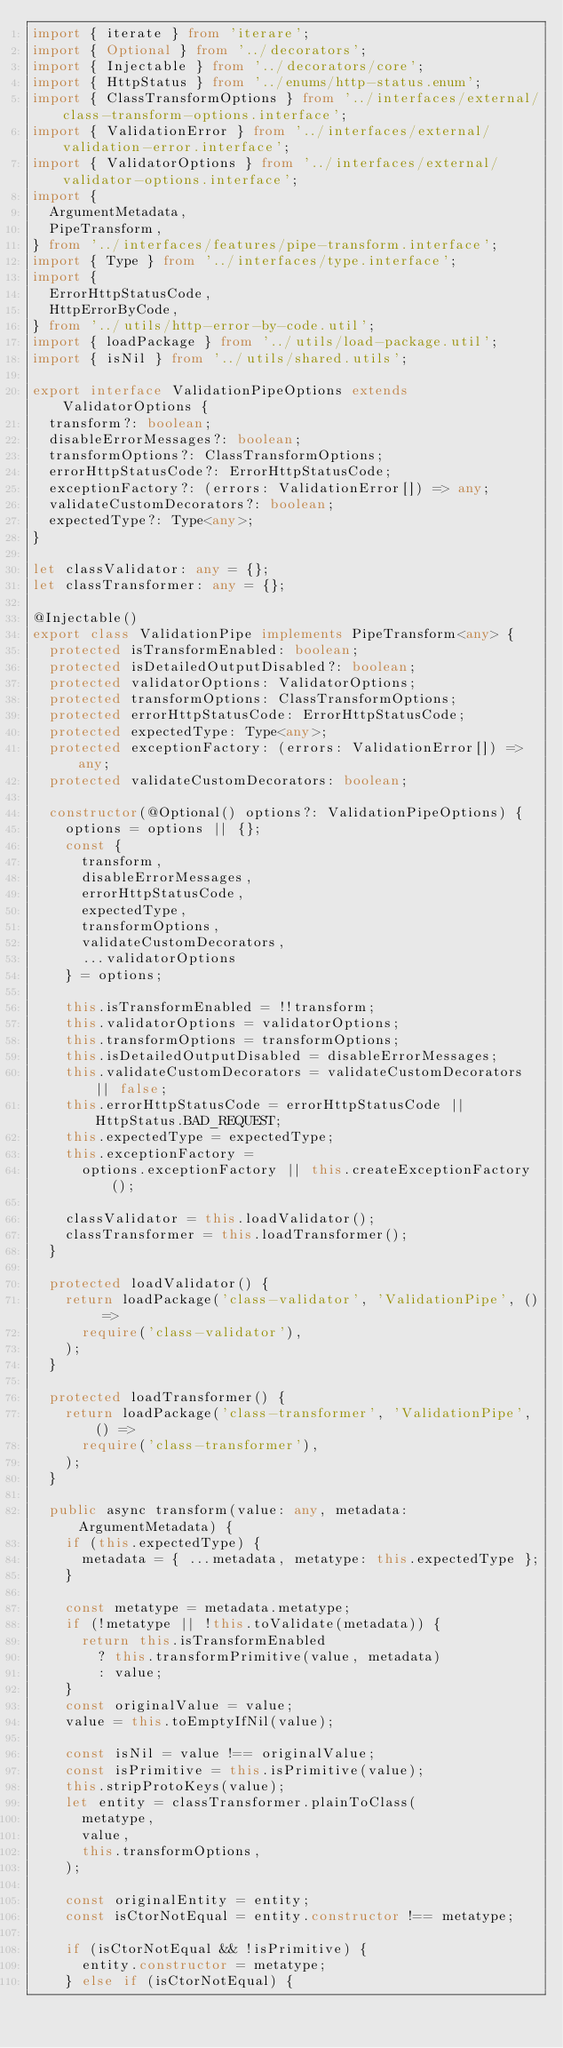Convert code to text. <code><loc_0><loc_0><loc_500><loc_500><_TypeScript_>import { iterate } from 'iterare';
import { Optional } from '../decorators';
import { Injectable } from '../decorators/core';
import { HttpStatus } from '../enums/http-status.enum';
import { ClassTransformOptions } from '../interfaces/external/class-transform-options.interface';
import { ValidationError } from '../interfaces/external/validation-error.interface';
import { ValidatorOptions } from '../interfaces/external/validator-options.interface';
import {
  ArgumentMetadata,
  PipeTransform,
} from '../interfaces/features/pipe-transform.interface';
import { Type } from '../interfaces/type.interface';
import {
  ErrorHttpStatusCode,
  HttpErrorByCode,
} from '../utils/http-error-by-code.util';
import { loadPackage } from '../utils/load-package.util';
import { isNil } from '../utils/shared.utils';

export interface ValidationPipeOptions extends ValidatorOptions {
  transform?: boolean;
  disableErrorMessages?: boolean;
  transformOptions?: ClassTransformOptions;
  errorHttpStatusCode?: ErrorHttpStatusCode;
  exceptionFactory?: (errors: ValidationError[]) => any;
  validateCustomDecorators?: boolean;
  expectedType?: Type<any>;
}

let classValidator: any = {};
let classTransformer: any = {};

@Injectable()
export class ValidationPipe implements PipeTransform<any> {
  protected isTransformEnabled: boolean;
  protected isDetailedOutputDisabled?: boolean;
  protected validatorOptions: ValidatorOptions;
  protected transformOptions: ClassTransformOptions;
  protected errorHttpStatusCode: ErrorHttpStatusCode;
  protected expectedType: Type<any>;
  protected exceptionFactory: (errors: ValidationError[]) => any;
  protected validateCustomDecorators: boolean;

  constructor(@Optional() options?: ValidationPipeOptions) {
    options = options || {};
    const {
      transform,
      disableErrorMessages,
      errorHttpStatusCode,
      expectedType,
      transformOptions,
      validateCustomDecorators,
      ...validatorOptions
    } = options;

    this.isTransformEnabled = !!transform;
    this.validatorOptions = validatorOptions;
    this.transformOptions = transformOptions;
    this.isDetailedOutputDisabled = disableErrorMessages;
    this.validateCustomDecorators = validateCustomDecorators || false;
    this.errorHttpStatusCode = errorHttpStatusCode || HttpStatus.BAD_REQUEST;
    this.expectedType = expectedType;
    this.exceptionFactory =
      options.exceptionFactory || this.createExceptionFactory();

    classValidator = this.loadValidator();
    classTransformer = this.loadTransformer();
  }

  protected loadValidator() {
    return loadPackage('class-validator', 'ValidationPipe', () =>
      require('class-validator'),
    );
  }

  protected loadTransformer() {
    return loadPackage('class-transformer', 'ValidationPipe', () =>
      require('class-transformer'),
    );
  }

  public async transform(value: any, metadata: ArgumentMetadata) {
    if (this.expectedType) {
      metadata = { ...metadata, metatype: this.expectedType };
    }

    const metatype = metadata.metatype;
    if (!metatype || !this.toValidate(metadata)) {
      return this.isTransformEnabled
        ? this.transformPrimitive(value, metadata)
        : value;
    }
    const originalValue = value;
    value = this.toEmptyIfNil(value);

    const isNil = value !== originalValue;
    const isPrimitive = this.isPrimitive(value);
    this.stripProtoKeys(value);
    let entity = classTransformer.plainToClass(
      metatype,
      value,
      this.transformOptions,
    );

    const originalEntity = entity;
    const isCtorNotEqual = entity.constructor !== metatype;

    if (isCtorNotEqual && !isPrimitive) {
      entity.constructor = metatype;
    } else if (isCtorNotEqual) {</code> 